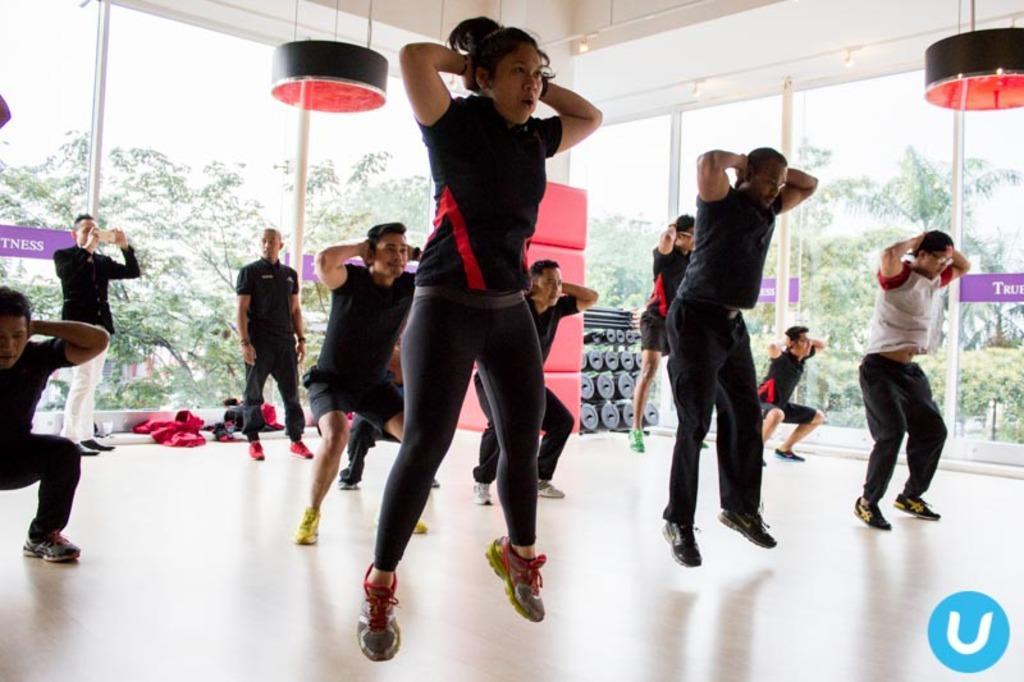Can you describe this image briefly? In this image we can see few people jumping. Some are standing. One person is holding something in the back. In the back there are poles. There are few items. On the floor there are clothes. And we can see trees in the background. 